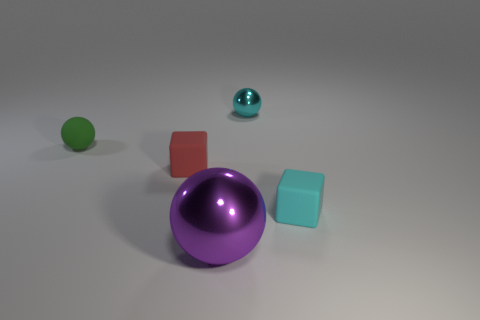Add 4 small cyan metal objects. How many objects exist? 9 Subtract all blocks. How many objects are left? 3 Subtract all big blue rubber things. Subtract all blocks. How many objects are left? 3 Add 2 big metal spheres. How many big metal spheres are left? 3 Add 4 purple things. How many purple things exist? 5 Subtract 0 yellow cubes. How many objects are left? 5 